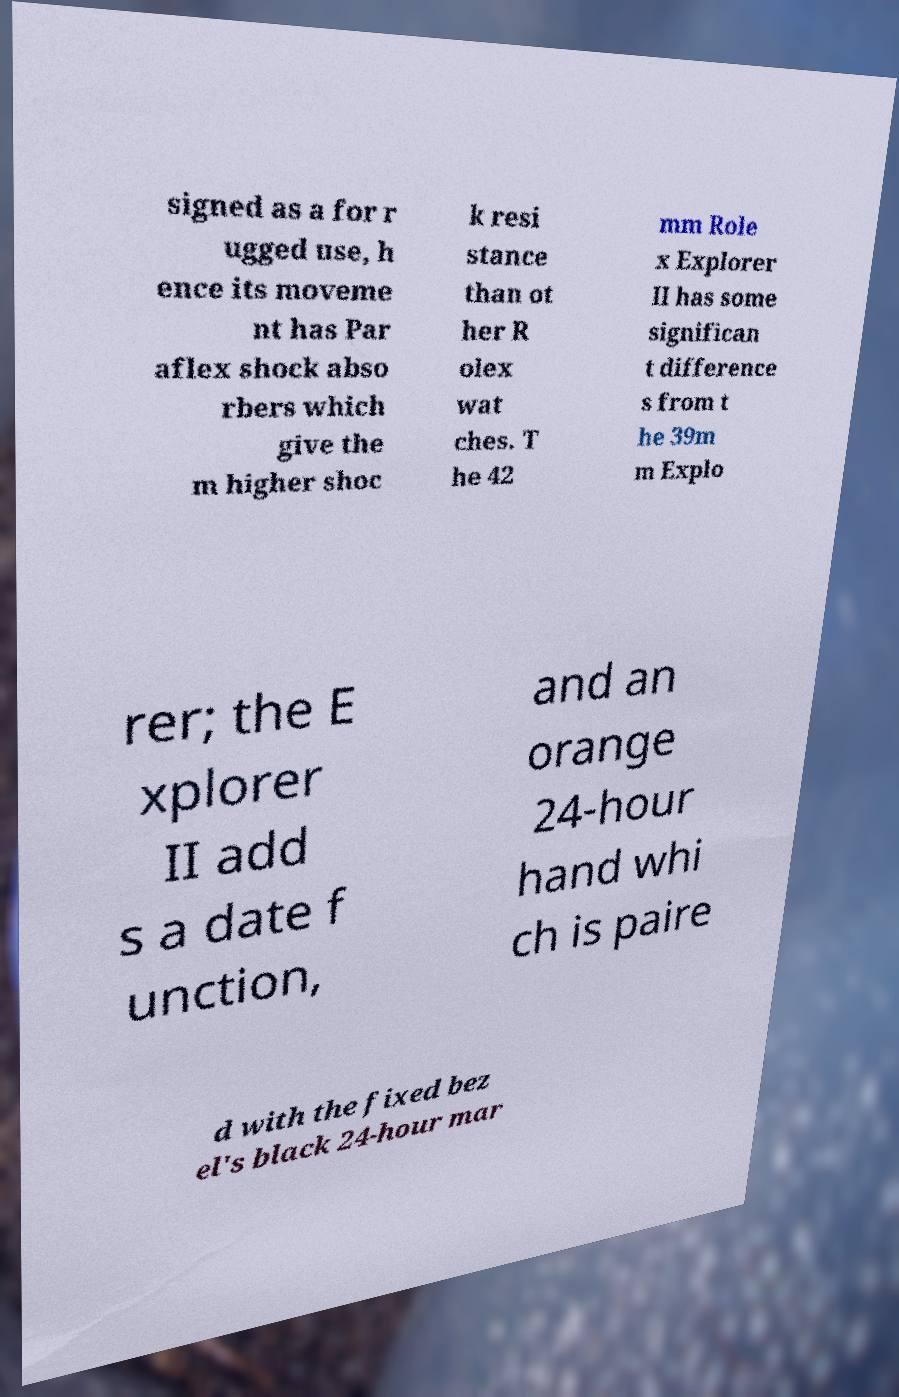What messages or text are displayed in this image? I need them in a readable, typed format. signed as a for r ugged use, h ence its moveme nt has Par aflex shock abso rbers which give the m higher shoc k resi stance than ot her R olex wat ches. T he 42 mm Role x Explorer II has some significan t difference s from t he 39m m Explo rer; the E xplorer II add s a date f unction, and an orange 24-hour hand whi ch is paire d with the fixed bez el's black 24-hour mar 